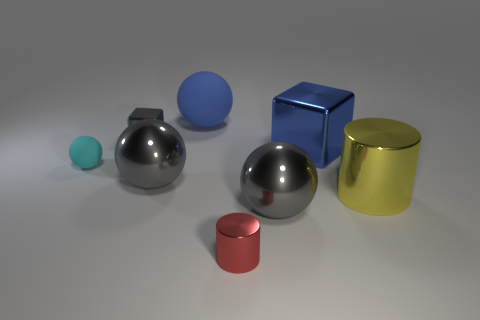What number of red metal spheres have the same size as the blue rubber thing?
Keep it short and to the point. 0. What is the shape of the yellow thing that is the same material as the small cylinder?
Your answer should be very brief. Cylinder. Is there a large rubber object of the same color as the big metallic cylinder?
Offer a terse response. No. What material is the blue sphere?
Ensure brevity in your answer.  Rubber. What number of objects are either big rubber things or large yellow matte things?
Keep it short and to the point. 1. There is a metal cylinder in front of the large yellow metallic thing; how big is it?
Your answer should be very brief. Small. What number of other things are the same material as the tiny cube?
Offer a very short reply. 5. There is a metallic cylinder that is behind the small red cylinder; are there any large things that are on the left side of it?
Offer a very short reply. Yes. Is there anything else that is the same shape as the small cyan matte object?
Offer a very short reply. Yes. What is the color of the other object that is the same shape as the small red thing?
Give a very brief answer. Yellow. 